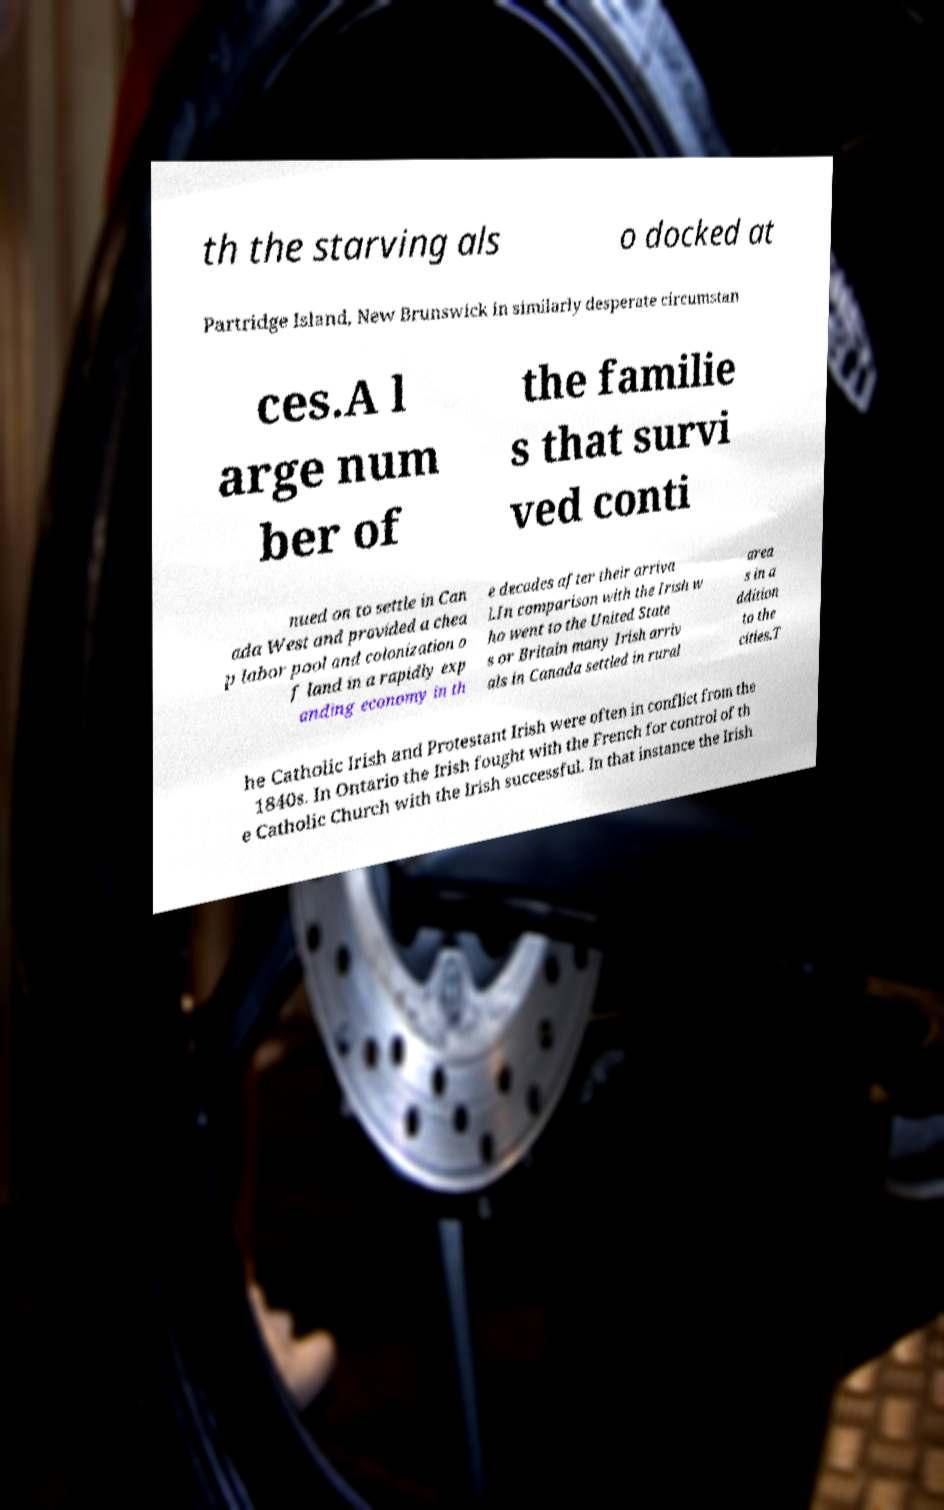I need the written content from this picture converted into text. Can you do that? th the starving als o docked at Partridge Island, New Brunswick in similarly desperate circumstan ces.A l arge num ber of the familie s that survi ved conti nued on to settle in Can ada West and provided a chea p labor pool and colonization o f land in a rapidly exp anding economy in th e decades after their arriva l.In comparison with the Irish w ho went to the United State s or Britain many Irish arriv als in Canada settled in rural area s in a ddition to the cities.T he Catholic Irish and Protestant Irish were often in conflict from the 1840s. In Ontario the Irish fought with the French for control of th e Catholic Church with the Irish successful. In that instance the Irish 